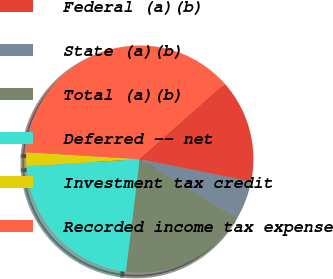<chart> <loc_0><loc_0><loc_500><loc_500><pie_chart><fcel>Federal (a)(b)<fcel>State (a)(b)<fcel>Total (a)(b)<fcel>Deferred -- net<fcel>Investment tax credit<fcel>Recorded income tax expense<nl><fcel>14.7%<fcel>5.53%<fcel>18.25%<fcel>22.03%<fcel>1.98%<fcel>37.51%<nl></chart> 